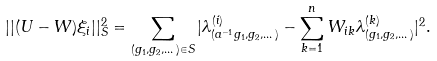<formula> <loc_0><loc_0><loc_500><loc_500>| | ( U - W ) \xi _ { i } | | _ { S } ^ { 2 } = \sum _ { ( g _ { 1 } , g _ { 2 } , \dots ) \in S } | \lambda _ { ( a ^ { - 1 } g _ { 1 } , g _ { 2 } , \dots ) } ^ { ( i ) } - \sum _ { k = 1 } ^ { n } W _ { i k } \lambda _ { ( g _ { 1 } , g _ { 2 } , \dots ) } ^ { ( k ) } | ^ { 2 } .</formula> 